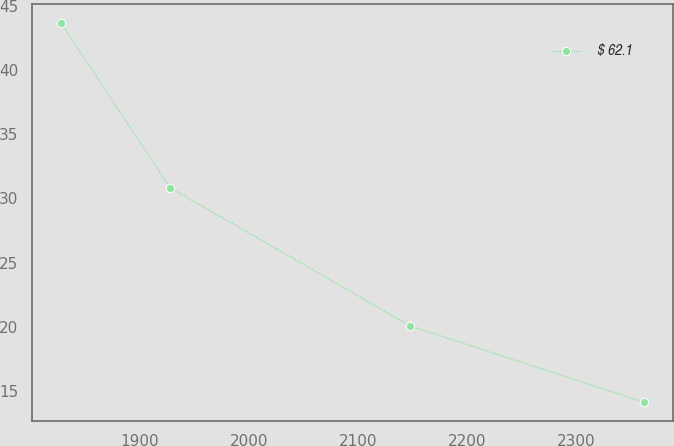Convert chart to OTSL. <chart><loc_0><loc_0><loc_500><loc_500><line_chart><ecel><fcel>$ 62.1<nl><fcel>1827.21<fcel>43.66<nl><fcel>1927.39<fcel>30.84<nl><fcel>2147.95<fcel>20.08<nl><fcel>2362.6<fcel>14.14<nl></chart> 